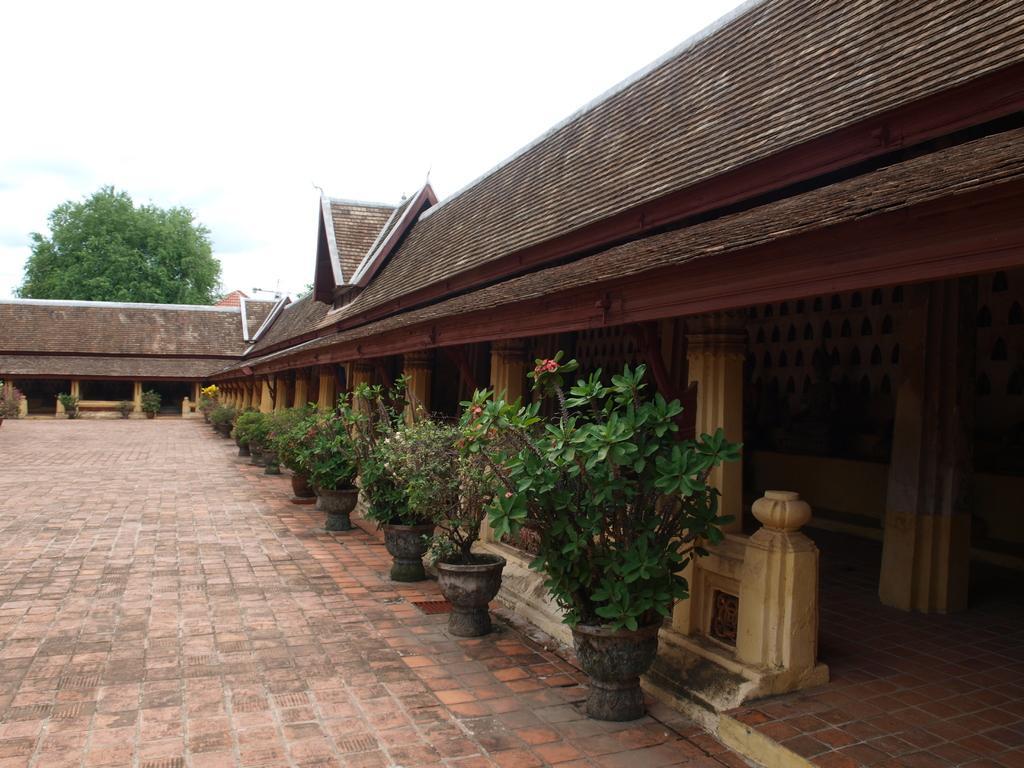Could you give a brief overview of what you see in this image? In this picture we can see a few flower pots on the path. We can see a few pillars and wooden objects in a house. There is a tree and the sky. 